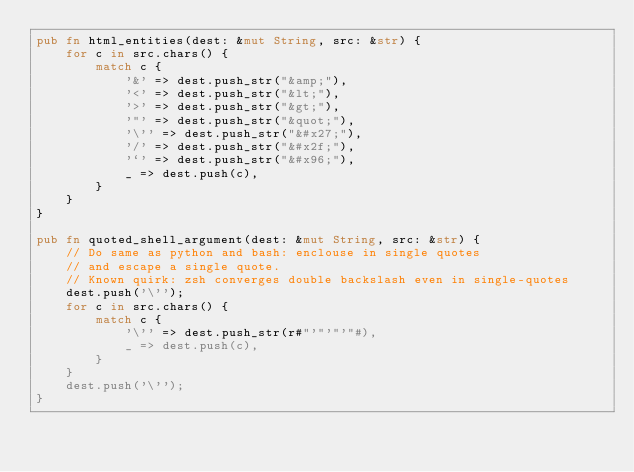Convert code to text. <code><loc_0><loc_0><loc_500><loc_500><_Rust_>pub fn html_entities(dest: &mut String, src: &str) {
    for c in src.chars() {
        match c {
            '&' => dest.push_str("&amp;"),
            '<' => dest.push_str("&lt;"),
            '>' => dest.push_str("&gt;"),
            '"' => dest.push_str("&quot;"),
            '\'' => dest.push_str("&#x27;"),
            '/' => dest.push_str("&#x2f;"),
            '`' => dest.push_str("&#x96;"),
            _ => dest.push(c),
        }
    }
}

pub fn quoted_shell_argument(dest: &mut String, src: &str) {
    // Do same as python and bash: enclouse in single quotes
    // and escape a single quote.
    // Known quirk: zsh converges double backslash even in single-quotes
    dest.push('\'');
    for c in src.chars() {
        match c {
            '\'' => dest.push_str(r#"'"'"'"#),
            _ => dest.push(c),
        }
    }
    dest.push('\'');
}
</code> 